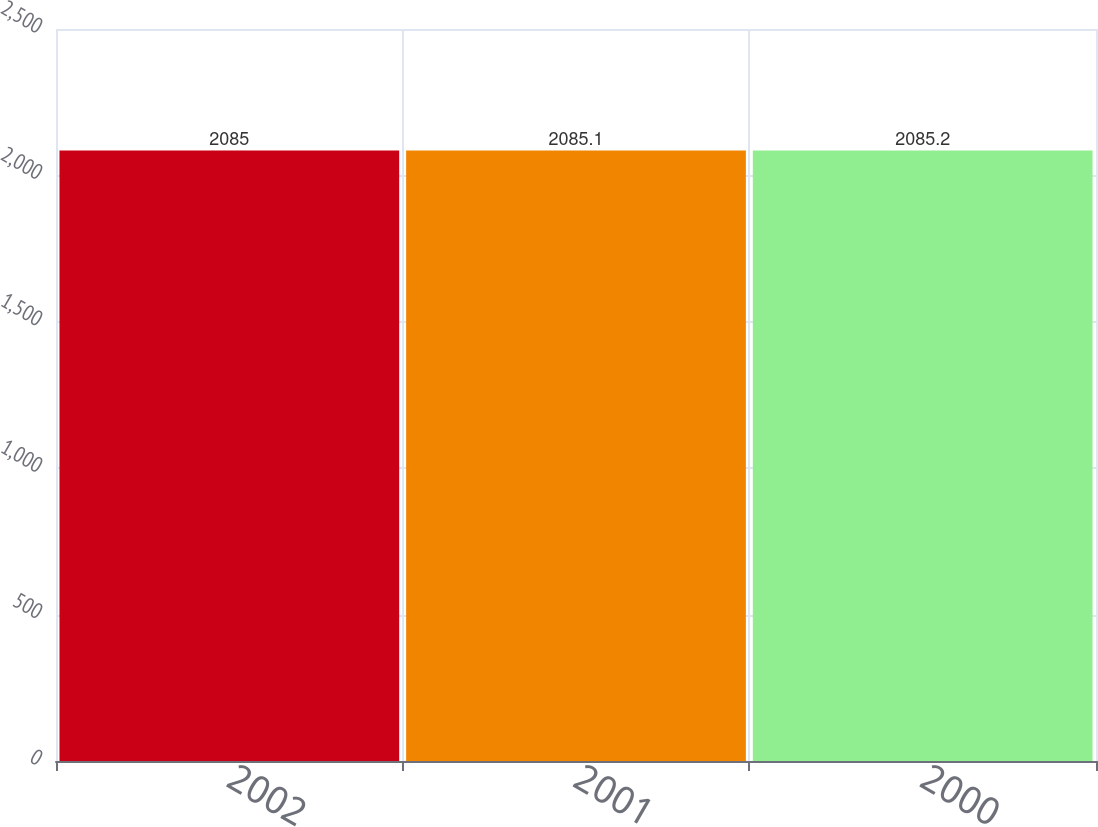<chart> <loc_0><loc_0><loc_500><loc_500><bar_chart><fcel>2002<fcel>2001<fcel>2000<nl><fcel>2085<fcel>2085.1<fcel>2085.2<nl></chart> 